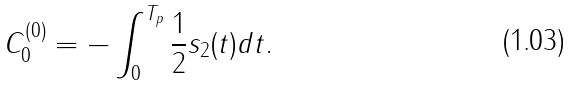<formula> <loc_0><loc_0><loc_500><loc_500>C _ { 0 } ^ { ( 0 ) } = - \int _ { 0 } ^ { T _ { p } } \frac { 1 } { 2 } s _ { 2 } ( t ) d t .</formula> 